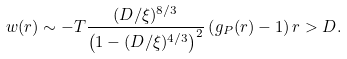<formula> <loc_0><loc_0><loc_500><loc_500>w ( r ) \sim - T \frac { ( D / \xi ) ^ { 8 / 3 } } { \left ( 1 - ( D / \xi ) ^ { 4 / 3 } \right ) ^ { 2 } } \left ( g _ { P } ( r ) - 1 \right ) r > D .</formula> 